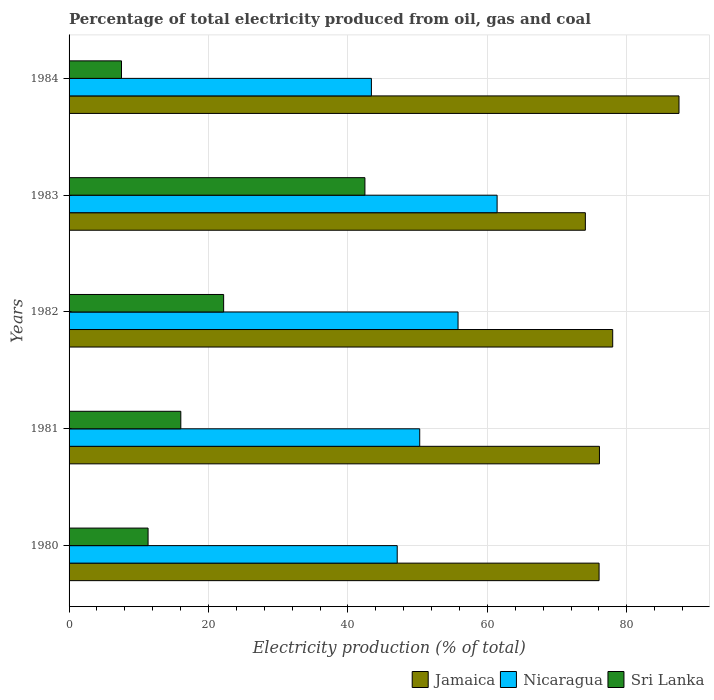How many groups of bars are there?
Give a very brief answer. 5. Are the number of bars on each tick of the Y-axis equal?
Keep it short and to the point. Yes. What is the label of the 1st group of bars from the top?
Provide a short and direct response. 1984. What is the electricity production in in Sri Lanka in 1982?
Keep it short and to the point. 22.17. Across all years, what is the maximum electricity production in in Jamaica?
Offer a very short reply. 87.48. Across all years, what is the minimum electricity production in in Nicaragua?
Provide a succinct answer. 43.36. In which year was the electricity production in in Jamaica maximum?
Offer a very short reply. 1984. What is the total electricity production in in Nicaragua in the graph?
Ensure brevity in your answer.  257.9. What is the difference between the electricity production in in Nicaragua in 1980 and that in 1982?
Your answer should be very brief. -8.72. What is the difference between the electricity production in in Jamaica in 1984 and the electricity production in in Sri Lanka in 1982?
Your response must be concise. 65.31. What is the average electricity production in in Nicaragua per year?
Give a very brief answer. 51.58. In the year 1980, what is the difference between the electricity production in in Sri Lanka and electricity production in in Jamaica?
Make the answer very short. -64.68. In how many years, is the electricity production in in Jamaica greater than 12 %?
Offer a terse response. 5. What is the ratio of the electricity production in in Nicaragua in 1982 to that in 1984?
Give a very brief answer. 1.29. Is the electricity production in in Jamaica in 1982 less than that in 1983?
Keep it short and to the point. No. What is the difference between the highest and the second highest electricity production in in Jamaica?
Provide a short and direct response. 9.51. What is the difference between the highest and the lowest electricity production in in Sri Lanka?
Provide a short and direct response. 34.91. Is the sum of the electricity production in in Nicaragua in 1982 and 1984 greater than the maximum electricity production in in Jamaica across all years?
Ensure brevity in your answer.  Yes. What does the 3rd bar from the top in 1983 represents?
Provide a succinct answer. Jamaica. What does the 1st bar from the bottom in 1980 represents?
Ensure brevity in your answer.  Jamaica. How many bars are there?
Ensure brevity in your answer.  15. How many years are there in the graph?
Make the answer very short. 5. Are the values on the major ticks of X-axis written in scientific E-notation?
Keep it short and to the point. No. Where does the legend appear in the graph?
Provide a succinct answer. Bottom right. How are the legend labels stacked?
Give a very brief answer. Horizontal. What is the title of the graph?
Your answer should be very brief. Percentage of total electricity produced from oil, gas and coal. What is the label or title of the X-axis?
Ensure brevity in your answer.  Electricity production (% of total). What is the label or title of the Y-axis?
Keep it short and to the point. Years. What is the Electricity production (% of total) in Jamaica in 1980?
Ensure brevity in your answer.  76.01. What is the Electricity production (% of total) of Nicaragua in 1980?
Keep it short and to the point. 47.06. What is the Electricity production (% of total) in Sri Lanka in 1980?
Provide a succinct answer. 11.33. What is the Electricity production (% of total) of Jamaica in 1981?
Offer a terse response. 76.07. What is the Electricity production (% of total) in Nicaragua in 1981?
Provide a succinct answer. 50.29. What is the Electricity production (% of total) of Sri Lanka in 1981?
Your answer should be very brief. 16.03. What is the Electricity production (% of total) of Jamaica in 1982?
Provide a succinct answer. 77.97. What is the Electricity production (% of total) in Nicaragua in 1982?
Offer a terse response. 55.79. What is the Electricity production (% of total) of Sri Lanka in 1982?
Your response must be concise. 22.17. What is the Electricity production (% of total) in Jamaica in 1983?
Your answer should be compact. 74.05. What is the Electricity production (% of total) in Nicaragua in 1983?
Your answer should be compact. 61.39. What is the Electricity production (% of total) in Sri Lanka in 1983?
Offer a terse response. 42.43. What is the Electricity production (% of total) of Jamaica in 1984?
Your response must be concise. 87.48. What is the Electricity production (% of total) in Nicaragua in 1984?
Ensure brevity in your answer.  43.36. What is the Electricity production (% of total) of Sri Lanka in 1984?
Your answer should be very brief. 7.52. Across all years, what is the maximum Electricity production (% of total) in Jamaica?
Ensure brevity in your answer.  87.48. Across all years, what is the maximum Electricity production (% of total) in Nicaragua?
Provide a succinct answer. 61.39. Across all years, what is the maximum Electricity production (% of total) of Sri Lanka?
Offer a terse response. 42.43. Across all years, what is the minimum Electricity production (% of total) of Jamaica?
Make the answer very short. 74.05. Across all years, what is the minimum Electricity production (% of total) in Nicaragua?
Ensure brevity in your answer.  43.36. Across all years, what is the minimum Electricity production (% of total) of Sri Lanka?
Your response must be concise. 7.52. What is the total Electricity production (% of total) of Jamaica in the graph?
Offer a terse response. 391.58. What is the total Electricity production (% of total) in Nicaragua in the graph?
Your answer should be very brief. 257.9. What is the total Electricity production (% of total) of Sri Lanka in the graph?
Your answer should be compact. 99.48. What is the difference between the Electricity production (% of total) of Jamaica in 1980 and that in 1981?
Provide a succinct answer. -0.05. What is the difference between the Electricity production (% of total) of Nicaragua in 1980 and that in 1981?
Keep it short and to the point. -3.23. What is the difference between the Electricity production (% of total) in Sri Lanka in 1980 and that in 1981?
Provide a short and direct response. -4.69. What is the difference between the Electricity production (% of total) in Jamaica in 1980 and that in 1982?
Offer a terse response. -1.96. What is the difference between the Electricity production (% of total) in Nicaragua in 1980 and that in 1982?
Give a very brief answer. -8.72. What is the difference between the Electricity production (% of total) of Sri Lanka in 1980 and that in 1982?
Your response must be concise. -10.84. What is the difference between the Electricity production (% of total) of Jamaica in 1980 and that in 1983?
Keep it short and to the point. 1.97. What is the difference between the Electricity production (% of total) in Nicaragua in 1980 and that in 1983?
Make the answer very short. -14.32. What is the difference between the Electricity production (% of total) of Sri Lanka in 1980 and that in 1983?
Provide a short and direct response. -31.1. What is the difference between the Electricity production (% of total) in Jamaica in 1980 and that in 1984?
Provide a short and direct response. -11.46. What is the difference between the Electricity production (% of total) in Nicaragua in 1980 and that in 1984?
Your answer should be compact. 3.7. What is the difference between the Electricity production (% of total) of Sri Lanka in 1980 and that in 1984?
Keep it short and to the point. 3.81. What is the difference between the Electricity production (% of total) of Jamaica in 1981 and that in 1982?
Provide a short and direct response. -1.9. What is the difference between the Electricity production (% of total) of Nicaragua in 1981 and that in 1982?
Offer a very short reply. -5.5. What is the difference between the Electricity production (% of total) of Sri Lanka in 1981 and that in 1982?
Offer a very short reply. -6.14. What is the difference between the Electricity production (% of total) in Jamaica in 1981 and that in 1983?
Your answer should be compact. 2.02. What is the difference between the Electricity production (% of total) of Nicaragua in 1981 and that in 1983?
Provide a succinct answer. -11.1. What is the difference between the Electricity production (% of total) in Sri Lanka in 1981 and that in 1983?
Your answer should be very brief. -26.41. What is the difference between the Electricity production (% of total) of Jamaica in 1981 and that in 1984?
Keep it short and to the point. -11.41. What is the difference between the Electricity production (% of total) of Nicaragua in 1981 and that in 1984?
Make the answer very short. 6.93. What is the difference between the Electricity production (% of total) in Sri Lanka in 1981 and that in 1984?
Your answer should be compact. 8.51. What is the difference between the Electricity production (% of total) in Jamaica in 1982 and that in 1983?
Give a very brief answer. 3.92. What is the difference between the Electricity production (% of total) in Nicaragua in 1982 and that in 1983?
Provide a succinct answer. -5.6. What is the difference between the Electricity production (% of total) of Sri Lanka in 1982 and that in 1983?
Offer a very short reply. -20.26. What is the difference between the Electricity production (% of total) of Jamaica in 1982 and that in 1984?
Offer a very short reply. -9.51. What is the difference between the Electricity production (% of total) of Nicaragua in 1982 and that in 1984?
Provide a succinct answer. 12.43. What is the difference between the Electricity production (% of total) of Sri Lanka in 1982 and that in 1984?
Your answer should be compact. 14.65. What is the difference between the Electricity production (% of total) in Jamaica in 1983 and that in 1984?
Your answer should be very brief. -13.43. What is the difference between the Electricity production (% of total) in Nicaragua in 1983 and that in 1984?
Ensure brevity in your answer.  18.03. What is the difference between the Electricity production (% of total) of Sri Lanka in 1983 and that in 1984?
Offer a terse response. 34.91. What is the difference between the Electricity production (% of total) in Jamaica in 1980 and the Electricity production (% of total) in Nicaragua in 1981?
Ensure brevity in your answer.  25.72. What is the difference between the Electricity production (% of total) of Jamaica in 1980 and the Electricity production (% of total) of Sri Lanka in 1981?
Give a very brief answer. 59.99. What is the difference between the Electricity production (% of total) in Nicaragua in 1980 and the Electricity production (% of total) in Sri Lanka in 1981?
Provide a short and direct response. 31.04. What is the difference between the Electricity production (% of total) in Jamaica in 1980 and the Electricity production (% of total) in Nicaragua in 1982?
Keep it short and to the point. 20.23. What is the difference between the Electricity production (% of total) of Jamaica in 1980 and the Electricity production (% of total) of Sri Lanka in 1982?
Offer a terse response. 53.85. What is the difference between the Electricity production (% of total) of Nicaragua in 1980 and the Electricity production (% of total) of Sri Lanka in 1982?
Your answer should be compact. 24.9. What is the difference between the Electricity production (% of total) of Jamaica in 1980 and the Electricity production (% of total) of Nicaragua in 1983?
Keep it short and to the point. 14.62. What is the difference between the Electricity production (% of total) of Jamaica in 1980 and the Electricity production (% of total) of Sri Lanka in 1983?
Your response must be concise. 33.58. What is the difference between the Electricity production (% of total) of Nicaragua in 1980 and the Electricity production (% of total) of Sri Lanka in 1983?
Offer a terse response. 4.63. What is the difference between the Electricity production (% of total) of Jamaica in 1980 and the Electricity production (% of total) of Nicaragua in 1984?
Your answer should be compact. 32.65. What is the difference between the Electricity production (% of total) in Jamaica in 1980 and the Electricity production (% of total) in Sri Lanka in 1984?
Keep it short and to the point. 68.5. What is the difference between the Electricity production (% of total) in Nicaragua in 1980 and the Electricity production (% of total) in Sri Lanka in 1984?
Make the answer very short. 39.55. What is the difference between the Electricity production (% of total) of Jamaica in 1981 and the Electricity production (% of total) of Nicaragua in 1982?
Your answer should be compact. 20.28. What is the difference between the Electricity production (% of total) in Jamaica in 1981 and the Electricity production (% of total) in Sri Lanka in 1982?
Your response must be concise. 53.9. What is the difference between the Electricity production (% of total) in Nicaragua in 1981 and the Electricity production (% of total) in Sri Lanka in 1982?
Your answer should be compact. 28.12. What is the difference between the Electricity production (% of total) of Jamaica in 1981 and the Electricity production (% of total) of Nicaragua in 1983?
Your answer should be compact. 14.68. What is the difference between the Electricity production (% of total) of Jamaica in 1981 and the Electricity production (% of total) of Sri Lanka in 1983?
Offer a very short reply. 33.64. What is the difference between the Electricity production (% of total) of Nicaragua in 1981 and the Electricity production (% of total) of Sri Lanka in 1983?
Your response must be concise. 7.86. What is the difference between the Electricity production (% of total) in Jamaica in 1981 and the Electricity production (% of total) in Nicaragua in 1984?
Provide a short and direct response. 32.71. What is the difference between the Electricity production (% of total) of Jamaica in 1981 and the Electricity production (% of total) of Sri Lanka in 1984?
Offer a terse response. 68.55. What is the difference between the Electricity production (% of total) of Nicaragua in 1981 and the Electricity production (% of total) of Sri Lanka in 1984?
Offer a terse response. 42.77. What is the difference between the Electricity production (% of total) in Jamaica in 1982 and the Electricity production (% of total) in Nicaragua in 1983?
Your answer should be very brief. 16.58. What is the difference between the Electricity production (% of total) in Jamaica in 1982 and the Electricity production (% of total) in Sri Lanka in 1983?
Give a very brief answer. 35.54. What is the difference between the Electricity production (% of total) in Nicaragua in 1982 and the Electricity production (% of total) in Sri Lanka in 1983?
Your response must be concise. 13.36. What is the difference between the Electricity production (% of total) in Jamaica in 1982 and the Electricity production (% of total) in Nicaragua in 1984?
Ensure brevity in your answer.  34.61. What is the difference between the Electricity production (% of total) in Jamaica in 1982 and the Electricity production (% of total) in Sri Lanka in 1984?
Your response must be concise. 70.45. What is the difference between the Electricity production (% of total) of Nicaragua in 1982 and the Electricity production (% of total) of Sri Lanka in 1984?
Ensure brevity in your answer.  48.27. What is the difference between the Electricity production (% of total) in Jamaica in 1983 and the Electricity production (% of total) in Nicaragua in 1984?
Ensure brevity in your answer.  30.69. What is the difference between the Electricity production (% of total) of Jamaica in 1983 and the Electricity production (% of total) of Sri Lanka in 1984?
Offer a very short reply. 66.53. What is the difference between the Electricity production (% of total) in Nicaragua in 1983 and the Electricity production (% of total) in Sri Lanka in 1984?
Offer a terse response. 53.87. What is the average Electricity production (% of total) in Jamaica per year?
Your answer should be very brief. 78.32. What is the average Electricity production (% of total) of Nicaragua per year?
Your answer should be very brief. 51.58. What is the average Electricity production (% of total) of Sri Lanka per year?
Provide a succinct answer. 19.89. In the year 1980, what is the difference between the Electricity production (% of total) of Jamaica and Electricity production (% of total) of Nicaragua?
Your answer should be compact. 28.95. In the year 1980, what is the difference between the Electricity production (% of total) of Jamaica and Electricity production (% of total) of Sri Lanka?
Make the answer very short. 64.68. In the year 1980, what is the difference between the Electricity production (% of total) in Nicaragua and Electricity production (% of total) in Sri Lanka?
Offer a very short reply. 35.73. In the year 1981, what is the difference between the Electricity production (% of total) of Jamaica and Electricity production (% of total) of Nicaragua?
Provide a succinct answer. 25.78. In the year 1981, what is the difference between the Electricity production (% of total) in Jamaica and Electricity production (% of total) in Sri Lanka?
Your answer should be very brief. 60.04. In the year 1981, what is the difference between the Electricity production (% of total) of Nicaragua and Electricity production (% of total) of Sri Lanka?
Keep it short and to the point. 34.27. In the year 1982, what is the difference between the Electricity production (% of total) of Jamaica and Electricity production (% of total) of Nicaragua?
Offer a terse response. 22.18. In the year 1982, what is the difference between the Electricity production (% of total) in Jamaica and Electricity production (% of total) in Sri Lanka?
Keep it short and to the point. 55.8. In the year 1982, what is the difference between the Electricity production (% of total) of Nicaragua and Electricity production (% of total) of Sri Lanka?
Your answer should be very brief. 33.62. In the year 1983, what is the difference between the Electricity production (% of total) in Jamaica and Electricity production (% of total) in Nicaragua?
Give a very brief answer. 12.66. In the year 1983, what is the difference between the Electricity production (% of total) in Jamaica and Electricity production (% of total) in Sri Lanka?
Offer a very short reply. 31.62. In the year 1983, what is the difference between the Electricity production (% of total) in Nicaragua and Electricity production (% of total) in Sri Lanka?
Your answer should be very brief. 18.96. In the year 1984, what is the difference between the Electricity production (% of total) in Jamaica and Electricity production (% of total) in Nicaragua?
Offer a very short reply. 44.12. In the year 1984, what is the difference between the Electricity production (% of total) in Jamaica and Electricity production (% of total) in Sri Lanka?
Your response must be concise. 79.96. In the year 1984, what is the difference between the Electricity production (% of total) in Nicaragua and Electricity production (% of total) in Sri Lanka?
Give a very brief answer. 35.84. What is the ratio of the Electricity production (% of total) of Nicaragua in 1980 to that in 1981?
Your response must be concise. 0.94. What is the ratio of the Electricity production (% of total) of Sri Lanka in 1980 to that in 1981?
Keep it short and to the point. 0.71. What is the ratio of the Electricity production (% of total) in Jamaica in 1980 to that in 1982?
Keep it short and to the point. 0.97. What is the ratio of the Electricity production (% of total) in Nicaragua in 1980 to that in 1982?
Your answer should be compact. 0.84. What is the ratio of the Electricity production (% of total) of Sri Lanka in 1980 to that in 1982?
Your answer should be compact. 0.51. What is the ratio of the Electricity production (% of total) of Jamaica in 1980 to that in 1983?
Provide a succinct answer. 1.03. What is the ratio of the Electricity production (% of total) in Nicaragua in 1980 to that in 1983?
Offer a terse response. 0.77. What is the ratio of the Electricity production (% of total) of Sri Lanka in 1980 to that in 1983?
Your answer should be very brief. 0.27. What is the ratio of the Electricity production (% of total) in Jamaica in 1980 to that in 1984?
Your answer should be very brief. 0.87. What is the ratio of the Electricity production (% of total) in Nicaragua in 1980 to that in 1984?
Provide a succinct answer. 1.09. What is the ratio of the Electricity production (% of total) of Sri Lanka in 1980 to that in 1984?
Offer a terse response. 1.51. What is the ratio of the Electricity production (% of total) in Jamaica in 1981 to that in 1982?
Your response must be concise. 0.98. What is the ratio of the Electricity production (% of total) of Nicaragua in 1981 to that in 1982?
Keep it short and to the point. 0.9. What is the ratio of the Electricity production (% of total) in Sri Lanka in 1981 to that in 1982?
Offer a terse response. 0.72. What is the ratio of the Electricity production (% of total) in Jamaica in 1981 to that in 1983?
Your response must be concise. 1.03. What is the ratio of the Electricity production (% of total) of Nicaragua in 1981 to that in 1983?
Ensure brevity in your answer.  0.82. What is the ratio of the Electricity production (% of total) of Sri Lanka in 1981 to that in 1983?
Offer a very short reply. 0.38. What is the ratio of the Electricity production (% of total) in Jamaica in 1981 to that in 1984?
Provide a short and direct response. 0.87. What is the ratio of the Electricity production (% of total) of Nicaragua in 1981 to that in 1984?
Make the answer very short. 1.16. What is the ratio of the Electricity production (% of total) in Sri Lanka in 1981 to that in 1984?
Offer a very short reply. 2.13. What is the ratio of the Electricity production (% of total) of Jamaica in 1982 to that in 1983?
Give a very brief answer. 1.05. What is the ratio of the Electricity production (% of total) in Nicaragua in 1982 to that in 1983?
Provide a short and direct response. 0.91. What is the ratio of the Electricity production (% of total) in Sri Lanka in 1982 to that in 1983?
Provide a short and direct response. 0.52. What is the ratio of the Electricity production (% of total) of Jamaica in 1982 to that in 1984?
Provide a succinct answer. 0.89. What is the ratio of the Electricity production (% of total) in Nicaragua in 1982 to that in 1984?
Your response must be concise. 1.29. What is the ratio of the Electricity production (% of total) in Sri Lanka in 1982 to that in 1984?
Your answer should be very brief. 2.95. What is the ratio of the Electricity production (% of total) in Jamaica in 1983 to that in 1984?
Make the answer very short. 0.85. What is the ratio of the Electricity production (% of total) in Nicaragua in 1983 to that in 1984?
Your answer should be compact. 1.42. What is the ratio of the Electricity production (% of total) of Sri Lanka in 1983 to that in 1984?
Your answer should be very brief. 5.64. What is the difference between the highest and the second highest Electricity production (% of total) of Jamaica?
Give a very brief answer. 9.51. What is the difference between the highest and the second highest Electricity production (% of total) of Nicaragua?
Offer a very short reply. 5.6. What is the difference between the highest and the second highest Electricity production (% of total) of Sri Lanka?
Keep it short and to the point. 20.26. What is the difference between the highest and the lowest Electricity production (% of total) of Jamaica?
Provide a succinct answer. 13.43. What is the difference between the highest and the lowest Electricity production (% of total) of Nicaragua?
Provide a short and direct response. 18.03. What is the difference between the highest and the lowest Electricity production (% of total) in Sri Lanka?
Your response must be concise. 34.91. 